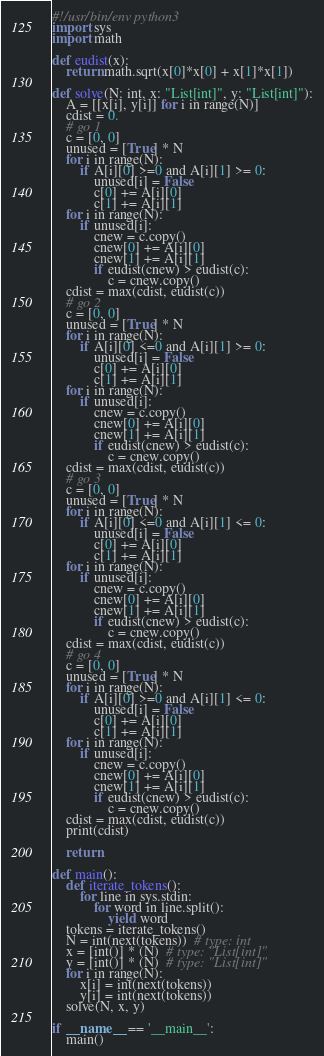Convert code to text. <code><loc_0><loc_0><loc_500><loc_500><_Python_>#!/usr/bin/env python3
import sys
import math

def eudist(x):
    return math.sqrt(x[0]*x[0] + x[1]*x[1])

def solve(N: int, x: "List[int]", y: "List[int]"):
    A = [[x[i], y[i]] for i in range(N)]
    cdist = 0.
    # go 1
    c = [0, 0]
    unused = [True] * N
    for i in range(N):
        if A[i][0] >=0 and A[i][1] >= 0:
            unused[i] = False
            c[0] += A[i][0]
            c[1] += A[i][1]
    for i in range(N):
        if unused[i]:
            cnew = c.copy()
            cnew[0] += A[i][0]
            cnew[1] += A[i][1]
            if eudist(cnew) > eudist(c):
                c = cnew.copy()
    cdist = max(cdist, eudist(c))
    # go 2
    c = [0, 0]
    unused = [True] * N
    for i in range(N):
        if A[i][0] <=0 and A[i][1] >= 0:
            unused[i] = False
            c[0] += A[i][0]
            c[1] += A[i][1]
    for i in range(N):
        if unused[i]:
            cnew = c.copy()
            cnew[0] += A[i][0]
            cnew[1] += A[i][1]
            if eudist(cnew) > eudist(c):
                c = cnew.copy()
    cdist = max(cdist, eudist(c))
    # go 3
    c = [0, 0]
    unused = [True] * N
    for i in range(N):
        if A[i][0] <=0 and A[i][1] <= 0:
            unused[i] = False
            c[0] += A[i][0]
            c[1] += A[i][1]
    for i in range(N):
        if unused[i]:
            cnew = c.copy()
            cnew[0] += A[i][0]
            cnew[1] += A[i][1]
            if eudist(cnew) > eudist(c):
                c = cnew.copy()
    cdist = max(cdist, eudist(c))
    # go 4
    c = [0, 0]
    unused = [True] * N
    for i in range(N):
        if A[i][0] >=0 and A[i][1] <= 0:
            unused[i] = False
            c[0] += A[i][0]
            c[1] += A[i][1]
    for i in range(N):
        if unused[i]:
            cnew = c.copy()
            cnew[0] += A[i][0]
            cnew[1] += A[i][1]
            if eudist(cnew) > eudist(c):
                c = cnew.copy()
    cdist = max(cdist, eudist(c))
    print(cdist)
    
    return
  
def main():
    def iterate_tokens():
        for line in sys.stdin:
            for word in line.split():
                yield word
    tokens = iterate_tokens()
    N = int(next(tokens))  # type: int
    x = [int()] * (N)  # type: "List[int]"
    y = [int()] * (N)  # type: "List[int]"
    for i in range(N):
        x[i] = int(next(tokens))
        y[i] = int(next(tokens))
    solve(N, x, y)

if __name__ == '__main__':
    main()
</code> 